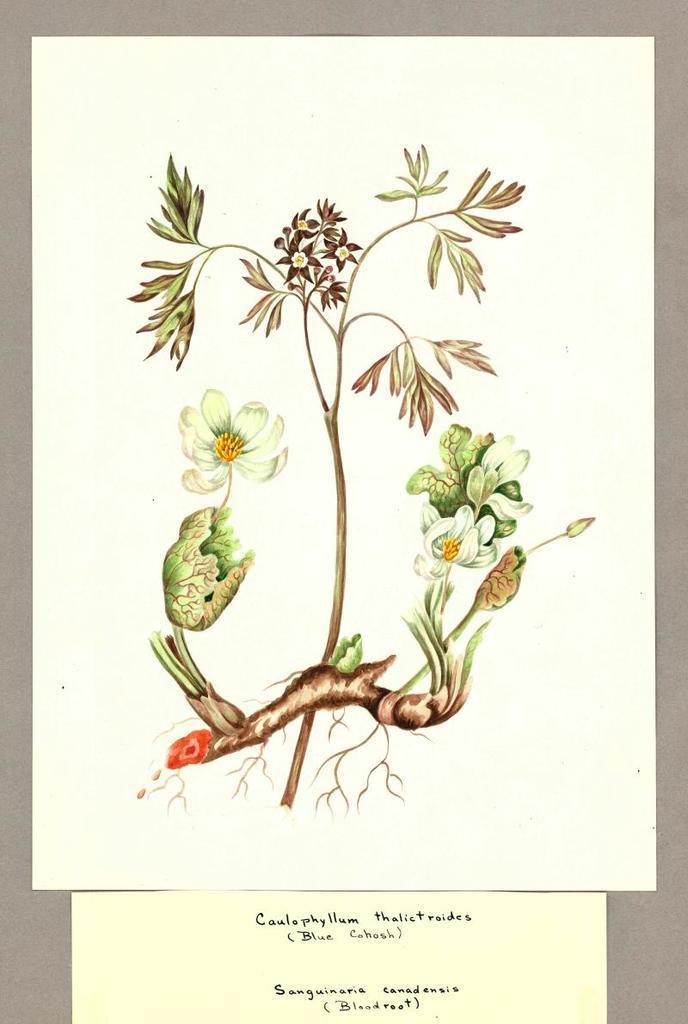Describe this image in one or two sentences. In this image we can see the pictures of flowers and stems on the paper. 